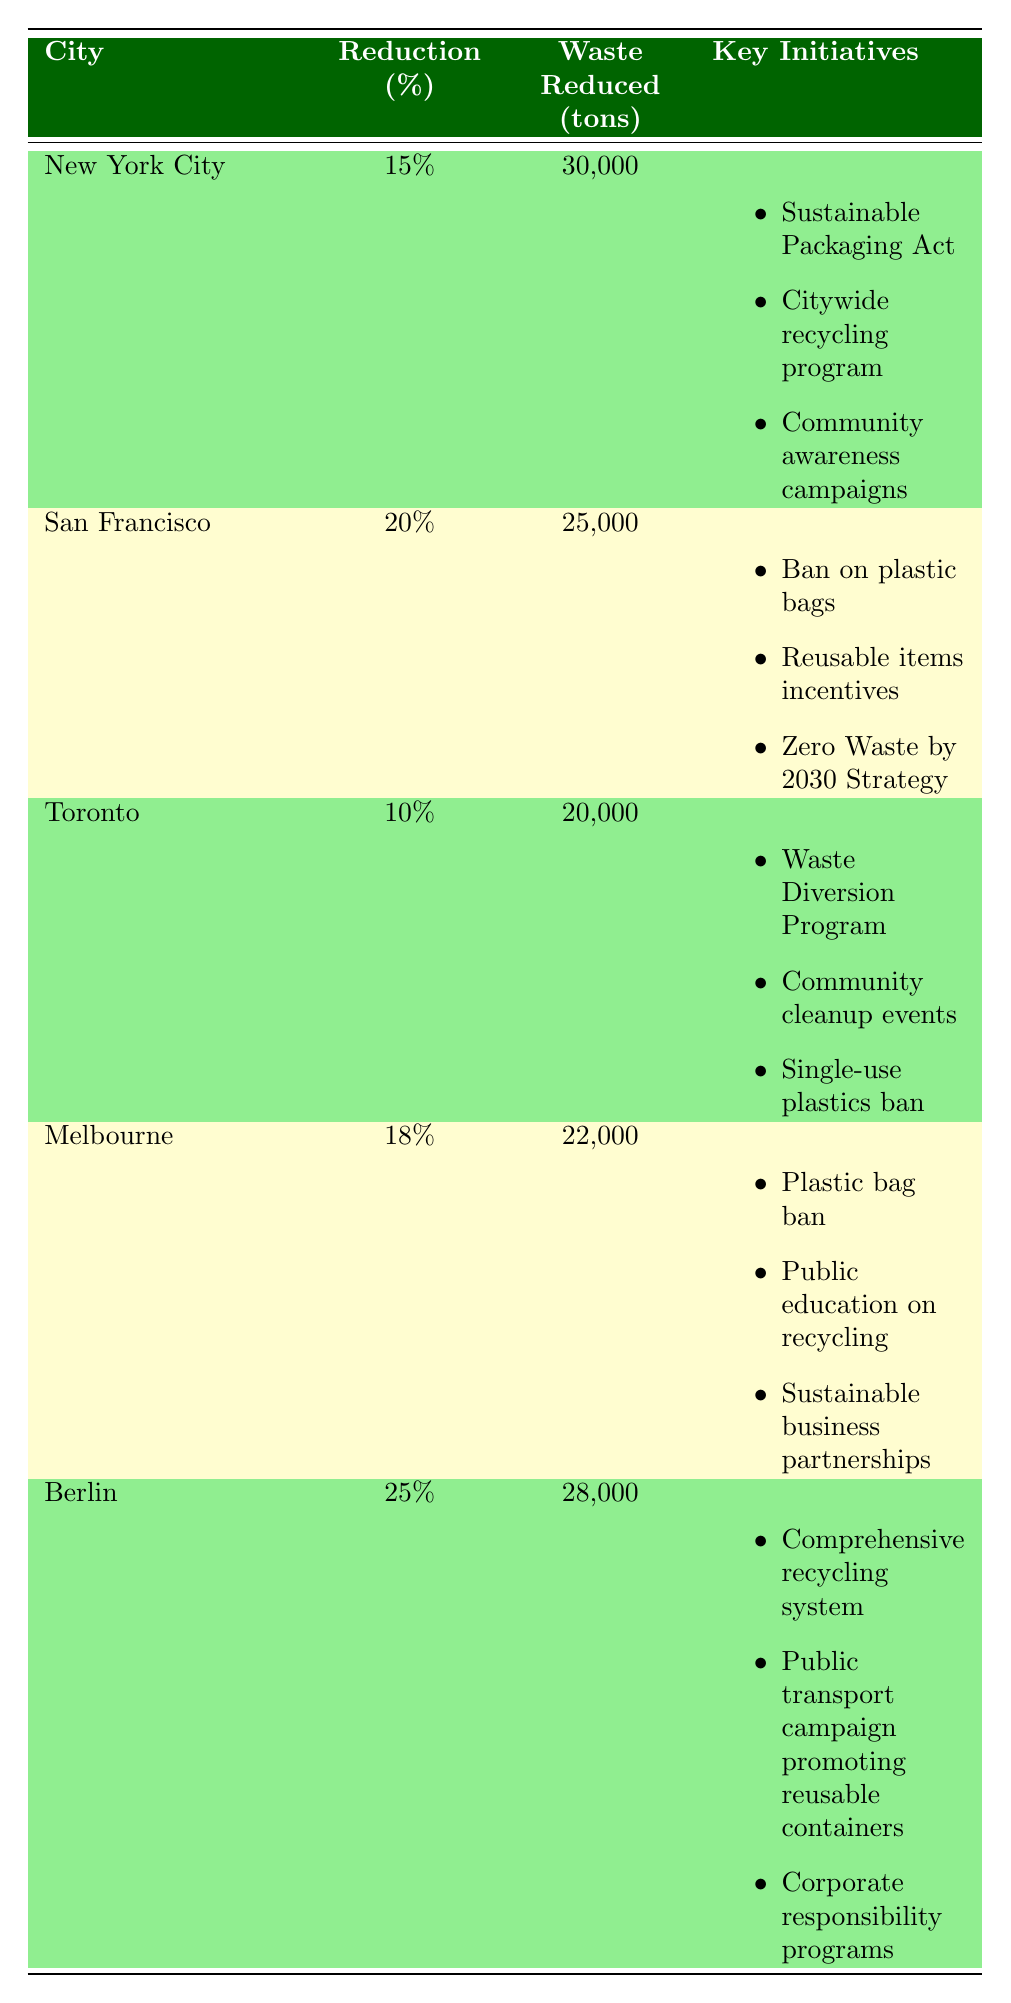What city had the highest plastic waste reduction percentage? Looking at the table, Berlin has the highest reduction percentage at 25%.
Answer: Berlin How much plastic waste was reduced in San Francisco? Referring to the table, San Francisco reduced 25,000 tons of plastic waste.
Answer: 25,000 tons Which city implemented a single-use plastics ban? The table indicates that Toronto has a single-use plastics ban as part of its initiatives.
Answer: Toronto What is the average percentage reduction across all cities listed? The percentage reductions are 15, 20, 10, 18, and 25. Adding these gives 88 and dividing by 5 cities gives an average of 17.6%.
Answer: 17.6% Was there a city that reduced plastic waste by less than 15%? Yes, Toronto reduced plastic waste by 10%, which is less than 15%.
Answer: Yes Which city reduced the most plastic waste in tons and what was the amount? The table shows that New York City reduced the most plastic waste, totaling 30,000 tons.
Answer: 30,000 tons How much total plastic waste was reduced by both New York City and Berlin combined? By summing the reductions of New York City (30,000 tons) and Berlin (28,000 tons), the total is 58,000 tons.
Answer: 58,000 tons Did any of the listed cities implement a comprehensive recycling system? Yes, Berlin implemented a comprehensive recycling system as one of its initiatives.
Answer: Yes 